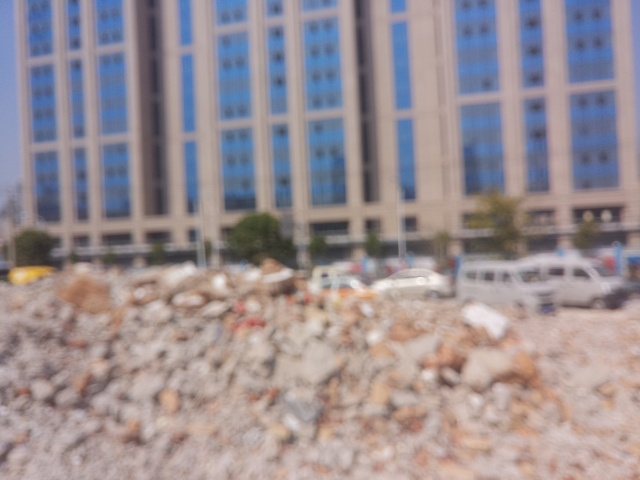What time of day does this image appear to have been captured? Based on the brightness and the clear skies, it appears the image was taken during daylight hours, possibly around midday when the sun is bright enough to reflect off the surfaces, even though specifics cannot be discerned. Is there any indication of activity or life in the image? Due to the blurriness, it's challenging to make out specific activities, but the presence of vehicles in the background suggests some level of urban activity and life in the vicinity. 